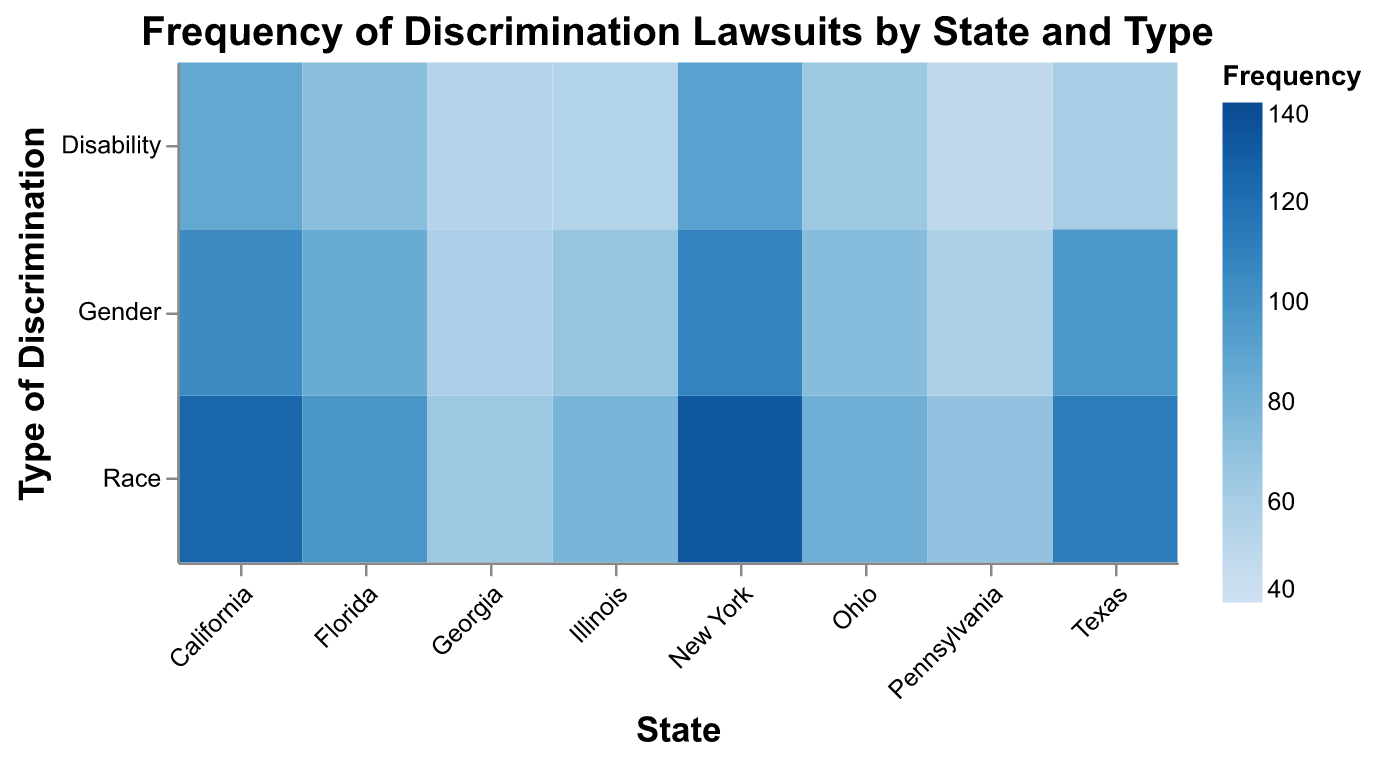What is the title of the heatmap? The title is prominently displayed at the top of the heatmap and reads: "Frequency of Discrimination Lawsuits by State and Type".
Answer: Frequency of Discrimination Lawsuits by State and Type Which state has the highest frequency of race discrimination lawsuits? The heatmap shows color intensity representing frequency, with New York having the darkest blue shade for race discrimination, which corresponds to the highest frequency.
Answer: New York How many types of discrimination are represented in the heatmap? The y-axis lists the types of discrimination. There are three categories: Race, Gender, and Disability.
Answer: 3 What is the frequency of disability discrimination lawsuits in Texas? Locate Texas on the x-axis and follow it to the row corresponding to Disability on the y-axis. The number within this cell is 60.
Answer: 60 How does the frequency of gender discrimination lawsuits in New York compare to California? New York has 109 and California has 104 gender discrimination lawsuits. Comparing these, New York's frequency is higher.
Answer: New York's frequency is higher What is the average frequency of gender discrimination lawsuits across all states? Sum the frequencies for gender discrimination across all states and divide by the number of states:
(104 + 97 + 85 + 109 + 67 + 58 + 73 + 59) / 8 
= 652 / 8 
= 81.5
Answer: 81.5 Which type of discrimination has the lowest frequency in Illinois? Refer to Illinois on the x-axis and compare the frequencies for Race (78), Gender (67), and Disability (55). Disability has the lowest frequency.
Answer: Disability What can you infer about the geographical distribution of race discrimination lawsuits from the heatmap? By observing the color intensity of race discrimination in each state, New York and California have the highest frequencies, while Georgia and Pennsylvania show the lowest. This indicates that race discrimination lawsuits are more common in larger states like New York and California.
Answer: More common in New York and California What is the total number of discrimination lawsuits (all types) in Florida? Sum the frequencies for all discrimination types in Florida: 98 (Race) + 85 (Gender) + 72 (Disability) = 255.
Answer: 255 